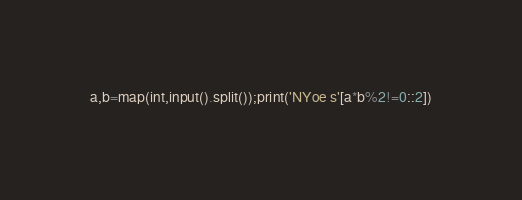<code> <loc_0><loc_0><loc_500><loc_500><_Python_>a,b=map(int,input().split());print('NYoe s'[a*b%2!=0::2])</code> 